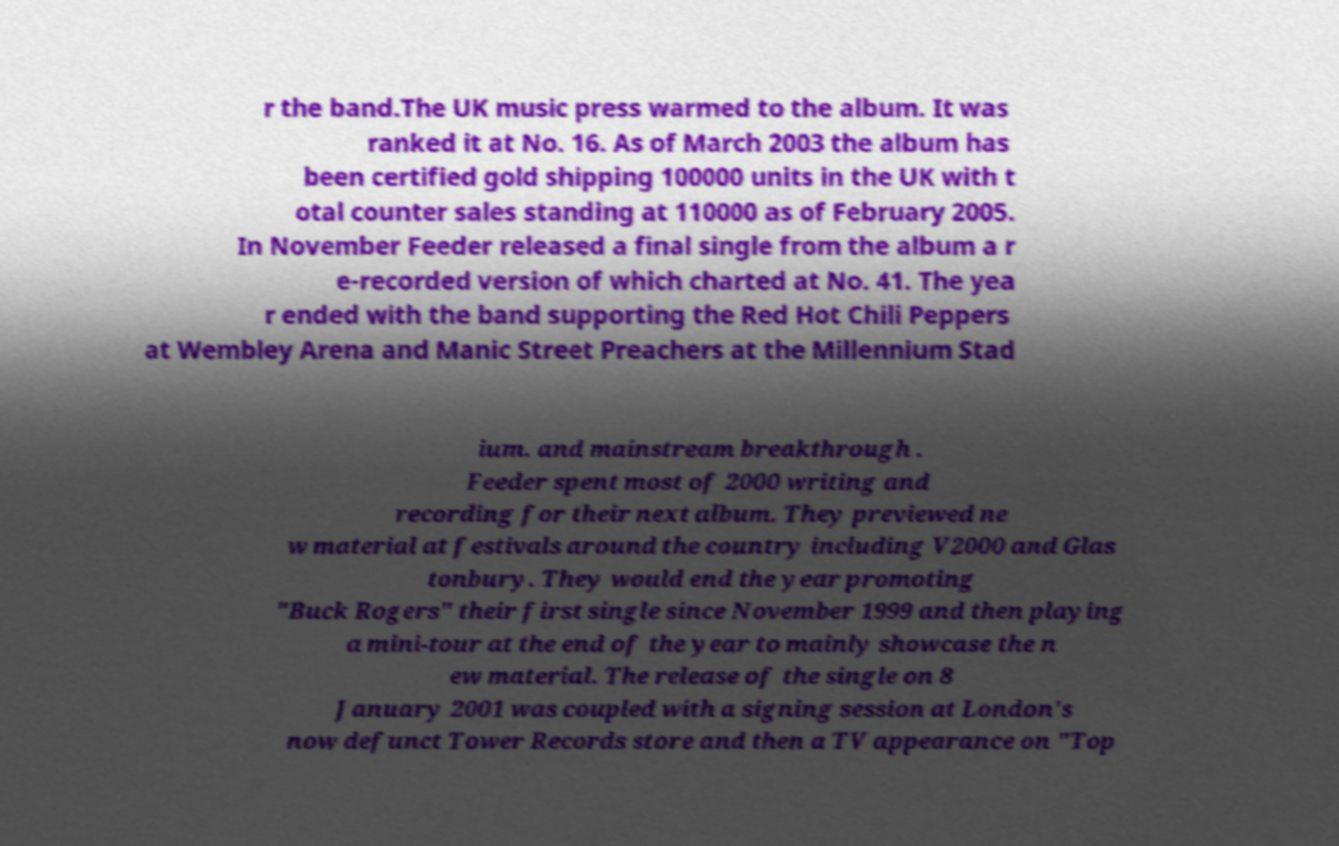Could you extract and type out the text from this image? r the band.The UK music press warmed to the album. It was ranked it at No. 16. As of March 2003 the album has been certified gold shipping 100000 units in the UK with t otal counter sales standing at 110000 as of February 2005. In November Feeder released a final single from the album a r e-recorded version of which charted at No. 41. The yea r ended with the band supporting the Red Hot Chili Peppers at Wembley Arena and Manic Street Preachers at the Millennium Stad ium. and mainstream breakthrough . Feeder spent most of 2000 writing and recording for their next album. They previewed ne w material at festivals around the country including V2000 and Glas tonbury. They would end the year promoting "Buck Rogers" their first single since November 1999 and then playing a mini-tour at the end of the year to mainly showcase the n ew material. The release of the single on 8 January 2001 was coupled with a signing session at London's now defunct Tower Records store and then a TV appearance on "Top 